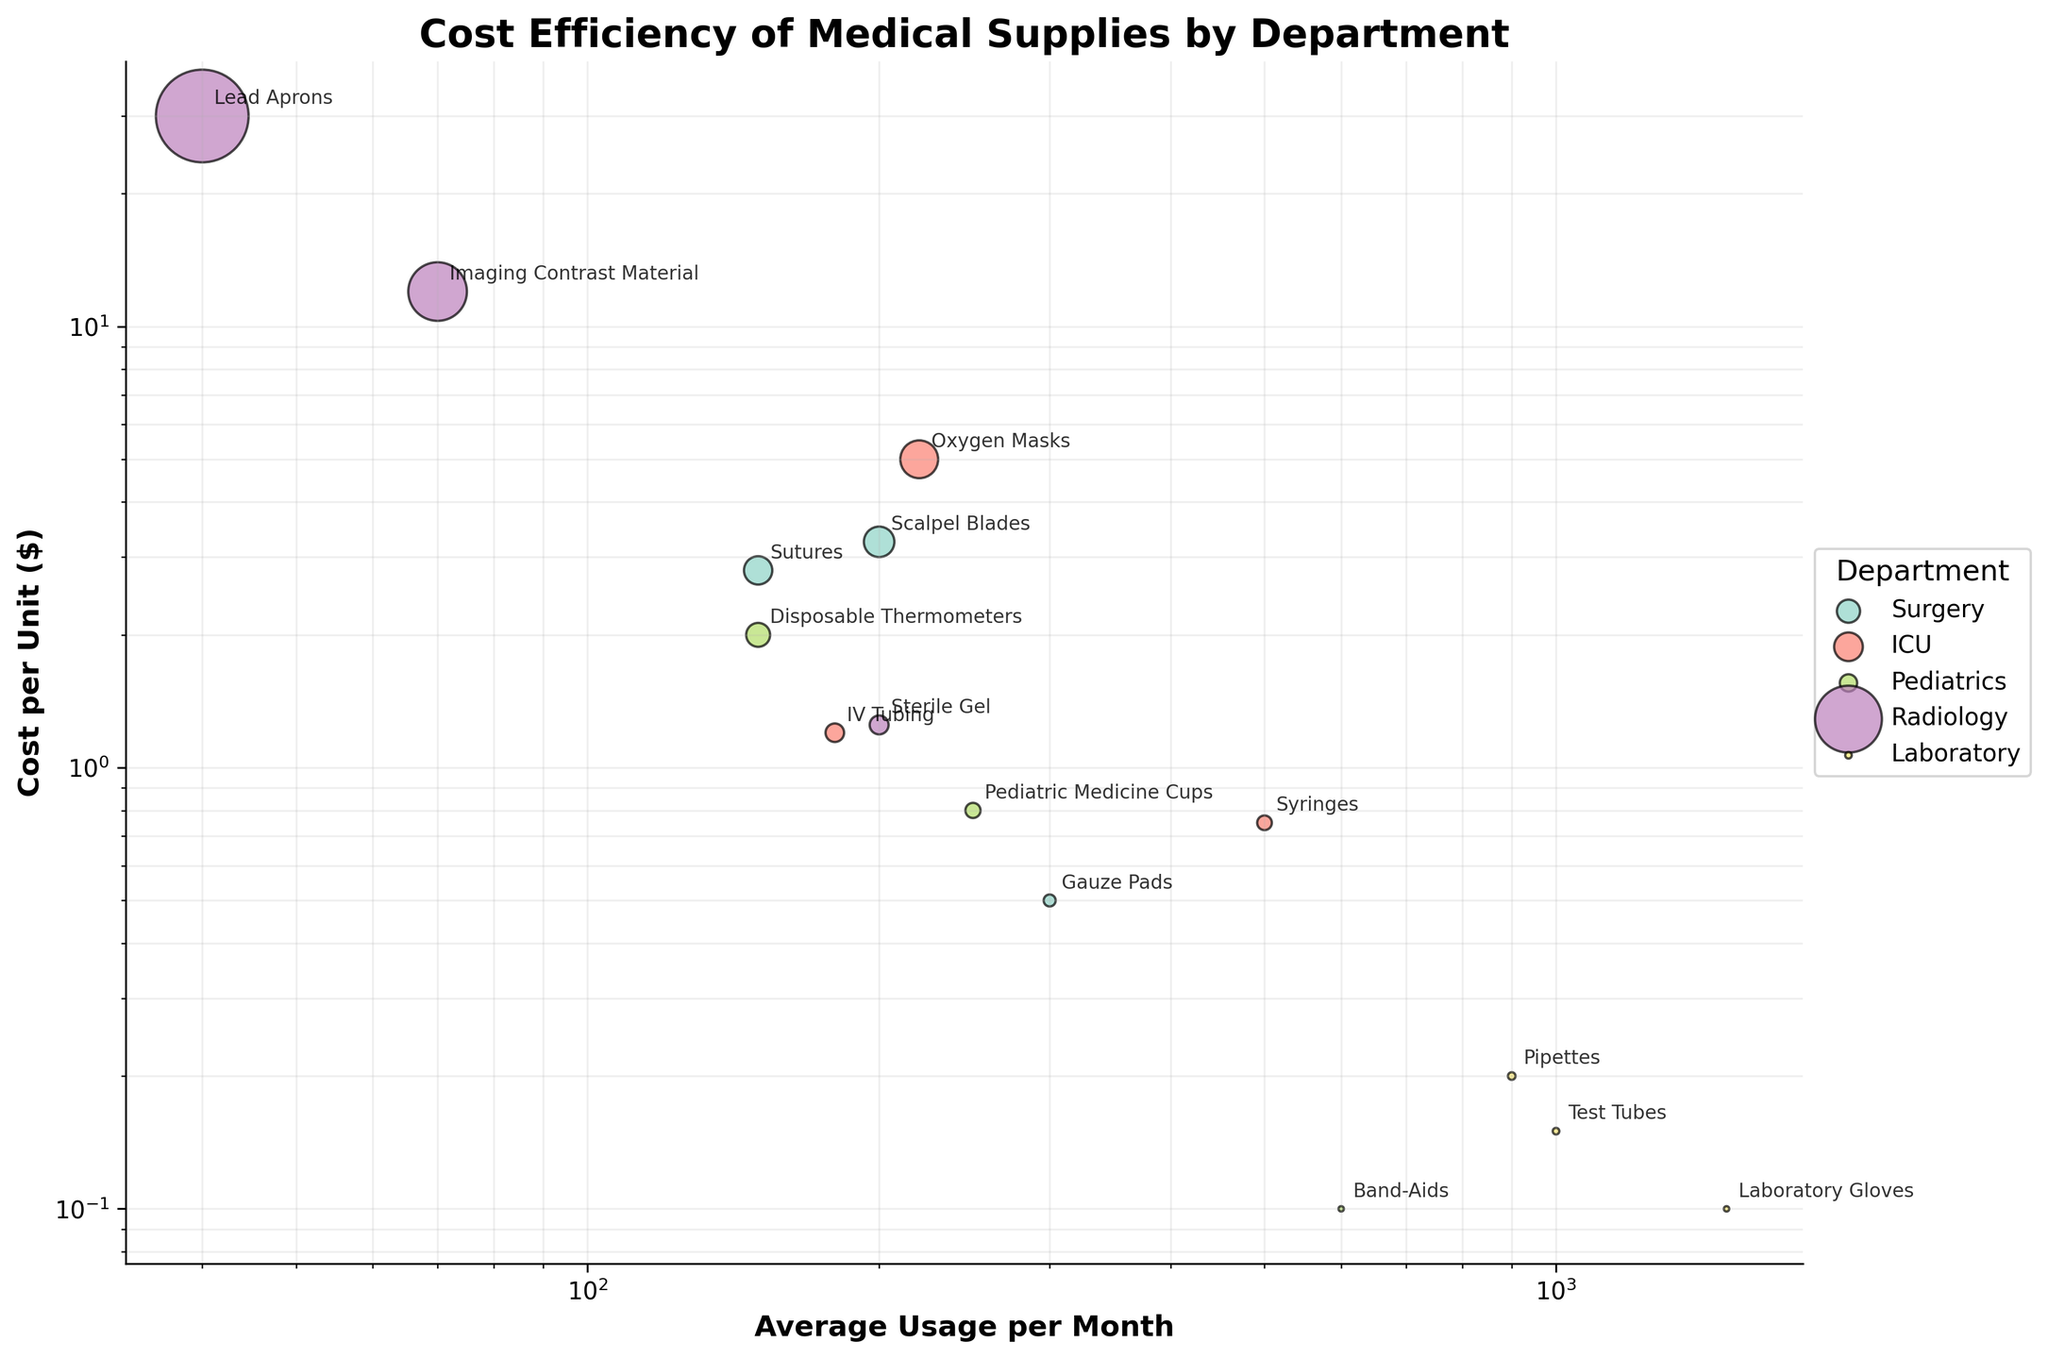What is the title of the figure? The title of the figure is generally located at the top center. In this case, it reads "Cost Efficiency of Medical Supplies by Department".
Answer: Cost Efficiency of Medical Supplies by Department Which department has the highest average usage per month for a single item? By examining the X-axis, you can see the department named Laboratory has the highest average usage per month with the item "Laboratory Gloves," which has a value of 1500.
Answer: Laboratory Which item has the highest cost per unit? By looking at the Y-axis, you can identify the item with the highest cost per unit, which is "Lead Aprons" in the Radiology department, with a cost of $30.
Answer: Lead Aprons How many items are listed under the Pediatrics department? By looking at the color legend and observing the number of Pediatrics items on the plot, you can count that there are 3 items: Band-Aids, Pediatric Medicine Cups, and Disposable Thermometers.
Answer: 3 What is the average cost per unit of all items in the ICU department? To calculate this, identify the items in the ICU: IV Tubing ($1.20), Oxygen Masks ($5.00), and Syringes ($0.75). Calculate the average: (1.20 + 5.00 + 0.75) / 3 = 6.95 / 3 = 2.32.
Answer: $2.32 Which item in the Surgery department has a usage frequency closest to the median value of the department? The Surgery department has Gauze Pads (300), Sutures (150), and Scalpel Blades (200). The median value is 200, so Scalpel Blades have the frequency closest to the median.
Answer: Scalpel Blades Compare the cost efficiency of Gauze Pads and Band-Aids. Which is more cost-efficient considering cost per unit and usage frequency? Gauze Pads have a cost per unit of $0.50 and an average usage of 300. Band-Aids have a cost per unit of $0.10 and an average usage of 600. Cost efficiency can be roughly estimated as (Cost per Unit / Usage Frequency). Gauze Pads: 0.50/300 ≈ 0.00167, Band-Aids: 0.10/600 ≈ 0.00017. Thus, Band-Aids are more cost-efficient.
Answer: Band-Aids Which item would result in the highest monthly cost considering both cost per unit and average usage per month? Multiply the cost per unit by average usage per month for all items. Laboratory Gloves have the highest value: 0.10 * 1500 = 150.
Answer: Laboratory Gloves What is the discernible pattern of correlation between cost per unit and average usage per month for all items in the Pediatrics department? Observe the scatter pattern for Pediatrics items: Band-Aids ($0.10, 600), Pediatric Medicine Cups ($0.80, 250), and Disposable Thermometers ($2.00, 150). Generally, as the average usage per month decreases, the cost per unit increases.
Answer: Negative correlation 